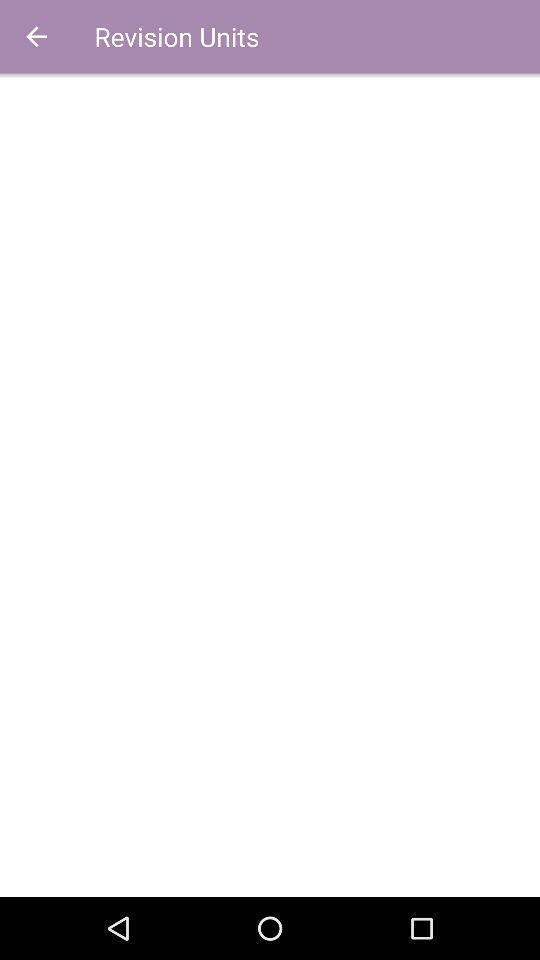Give me a summary of this screen capture. Revision units page of a learning app. 